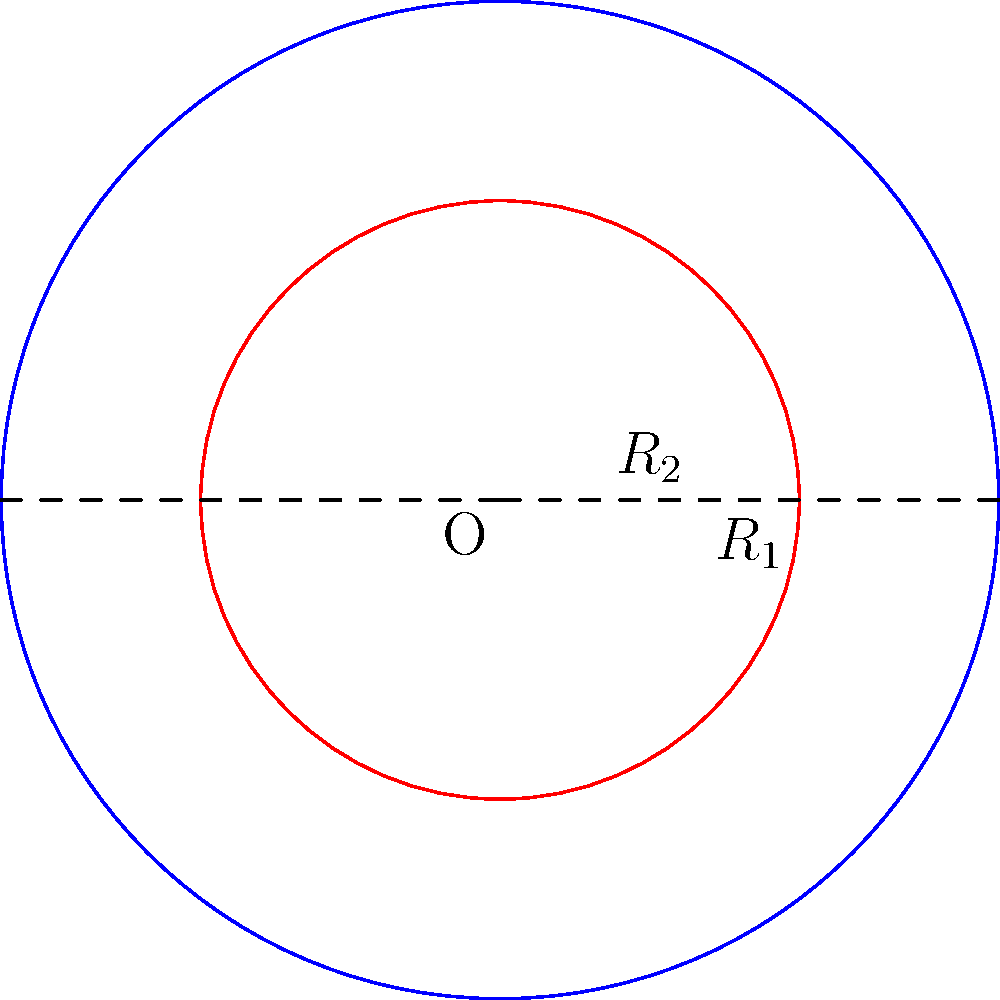In an augmented reality application, you need to calculate the area of a ring-shaped object. The object is represented by two concentric circles with radii $R_1 = 5$ units and $R_2 = 3$ units, as shown in the diagram. What is the area of the region between these two circles? To find the area of the region between two concentric circles, we need to:

1. Calculate the area of the larger circle (with radius $R_1$):
   $$A_1 = \pi R_1^2 = \pi (5^2) = 25\pi$$

2. Calculate the area of the smaller circle (with radius $R_2$):
   $$A_2 = \pi R_2^2 = \pi (3^2) = 9\pi$$

3. Subtract the area of the smaller circle from the area of the larger circle:
   $$A_{ring} = A_1 - A_2 = 25\pi - 9\pi = 16\pi$$

Therefore, the area of the region between the two concentric circles is $16\pi$ square units.
Answer: $16\pi$ square units 